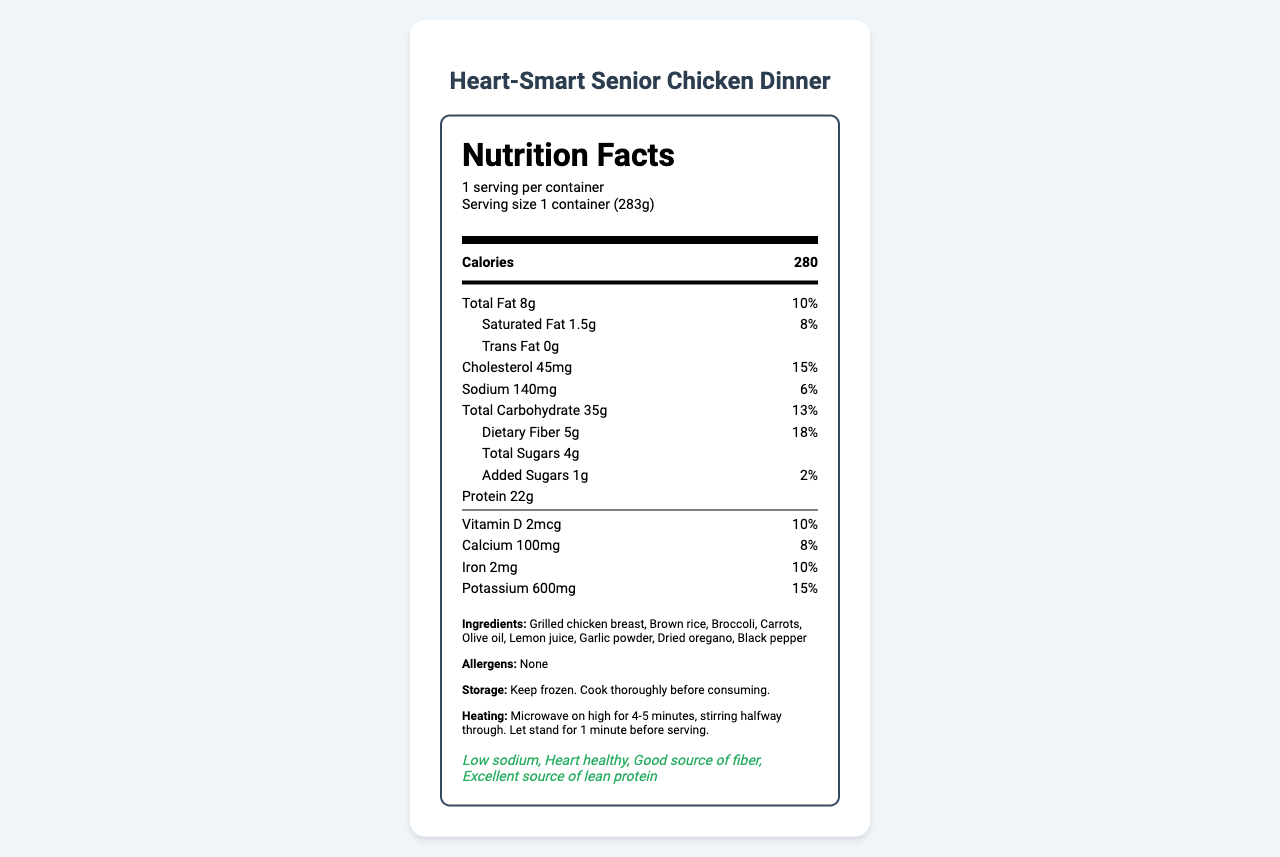what is the serving size of the Heart-Smart Senior Chicken Dinner? The serving size is clearly mentioned as "1 container (283g)" in the document.
Answer: 1 container (283g) how many calories are there per serving? According to the document, there are 280 calories per serving.
Answer: 280 what is the total amount of dietary fiber in the meal? The document states that the dietary fiber amount is 5g.
Answer: 5g what is the sodium content in this meal? The sodium content is listed as 140mg in the document.
Answer: 140mg name three key ingredients in the Heart-Smart Senior Chicken Dinner. The ingredients section lists these three key ingredients among others.
Answer: Grilled chicken breast, Brown rice, Broccoli how much protein does this meal provide? The protein content is mentioned as 22g in the document.
Answer: 22g which of these has the highest daily value percentage in the meal? A. Saturated Fat B. Cholesterol C. Dietary Fiber D. Calcium Cholesterol has a daily value of 15%, which is higher than the others listed.
Answer: B which of the following is NOT listed as an ingredient in the Heart-Smart Senior Chicken Dinner? A. Black pepper B. Olive oil C. Quinoa Quinoa is not mentioned in the ingredients list; Black pepper and Olive oil are listed.
Answer: C is this meal suitable for someone with hypertension? The meal is labeled as "Low sodium" and "Heart healthy," making it suitable for individuals with hypertension.
Answer: Yes is this meal a good source of fiber? The meal has 5g of dietary fiber, which accounts for 18% of the daily value, qualifying it as a good source of fiber.
Answer: Yes describe the main nutritional benefits of the Heart-Smart Senior Chicken Dinner. The document outlines that the meal is specially formulated to support cardiovascular health and muscle maintenance for seniors. It provides a balanced mix of lean protein, complex carbohydrates, dietary fiber, and essential vitamins and minerals.
Answer: The Heart-Smart Senior Chicken Dinner is a low-sodium, heart-healthy meal that provides 280 calories per serving. It includes 22g of lean protein, 5g of dietary fiber, and essential vitamins and minerals like Vitamin D, Calcium, Iron, and Potassium, making it suitable for seniors with hypertension. The meal supports cardiovascular health and muscle maintenance. how many containers are there in each serving? The document specifies the serving size as "1 container (283g)" but doesn't mention the number of containers per serving.
Answer: Not enough information what are the health claims associated with this meal? The health claims are listed under the section "health claims," stating that the meal is low sodium, heart healthy, a good source of fiber, and an excellent source of lean protein.
Answer: Low sodium, Heart healthy, Good source of fiber, Excellent source of lean protein 